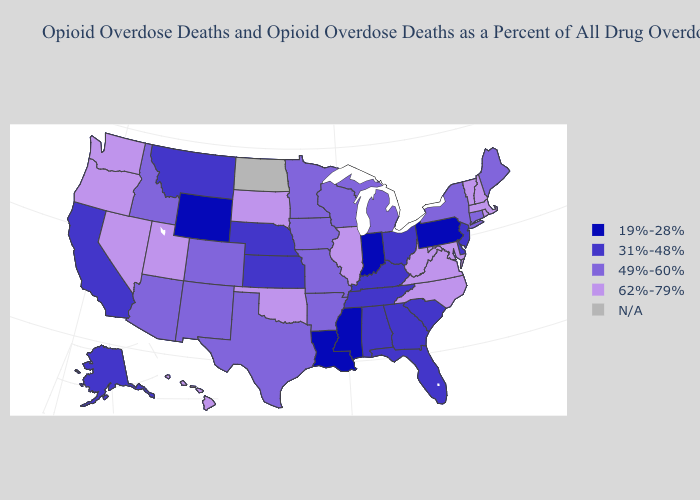What is the value of Nevada?
Short answer required. 62%-79%. Does the first symbol in the legend represent the smallest category?
Concise answer only. Yes. What is the lowest value in the Northeast?
Short answer required. 19%-28%. What is the lowest value in the USA?
Keep it brief. 19%-28%. Name the states that have a value in the range 49%-60%?
Short answer required. Arizona, Arkansas, Colorado, Connecticut, Idaho, Iowa, Maine, Michigan, Minnesota, Missouri, New Mexico, New York, Texas, Wisconsin. Among the states that border Montana , does Idaho have the lowest value?
Give a very brief answer. No. Name the states that have a value in the range 19%-28%?
Keep it brief. Indiana, Louisiana, Mississippi, Pennsylvania, Wyoming. Does the first symbol in the legend represent the smallest category?
Quick response, please. Yes. Does South Dakota have the highest value in the MidWest?
Answer briefly. Yes. Which states have the highest value in the USA?
Write a very short answer. Hawaii, Illinois, Maryland, Massachusetts, Nevada, New Hampshire, North Carolina, Oklahoma, Oregon, Rhode Island, South Dakota, Utah, Vermont, Virginia, Washington, West Virginia. What is the highest value in the West ?
Give a very brief answer. 62%-79%. What is the lowest value in states that border Louisiana?
Be succinct. 19%-28%. Does Montana have the lowest value in the USA?
Quick response, please. No. Which states have the lowest value in the USA?
Give a very brief answer. Indiana, Louisiana, Mississippi, Pennsylvania, Wyoming. 